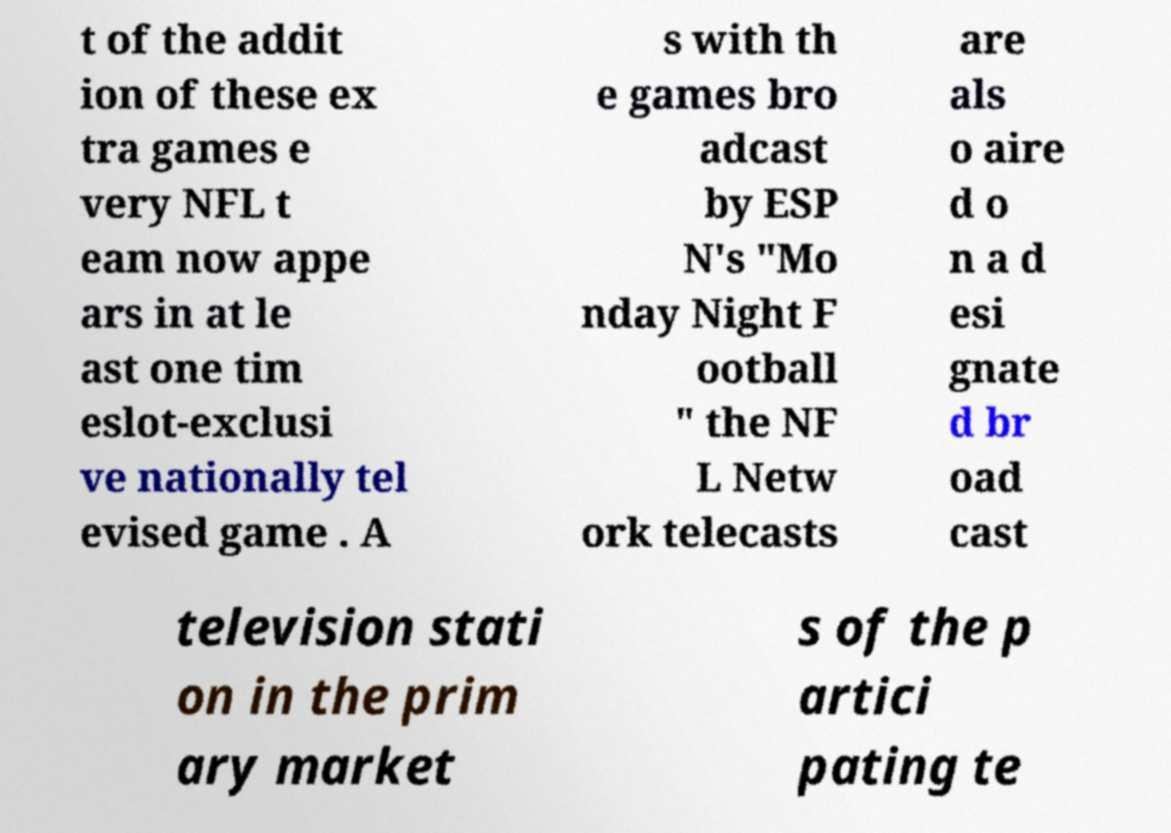Please identify and transcribe the text found in this image. t of the addit ion of these ex tra games e very NFL t eam now appe ars in at le ast one tim eslot-exclusi ve nationally tel evised game . A s with th e games bro adcast by ESP N's "Mo nday Night F ootball " the NF L Netw ork telecasts are als o aire d o n a d esi gnate d br oad cast television stati on in the prim ary market s of the p artici pating te 